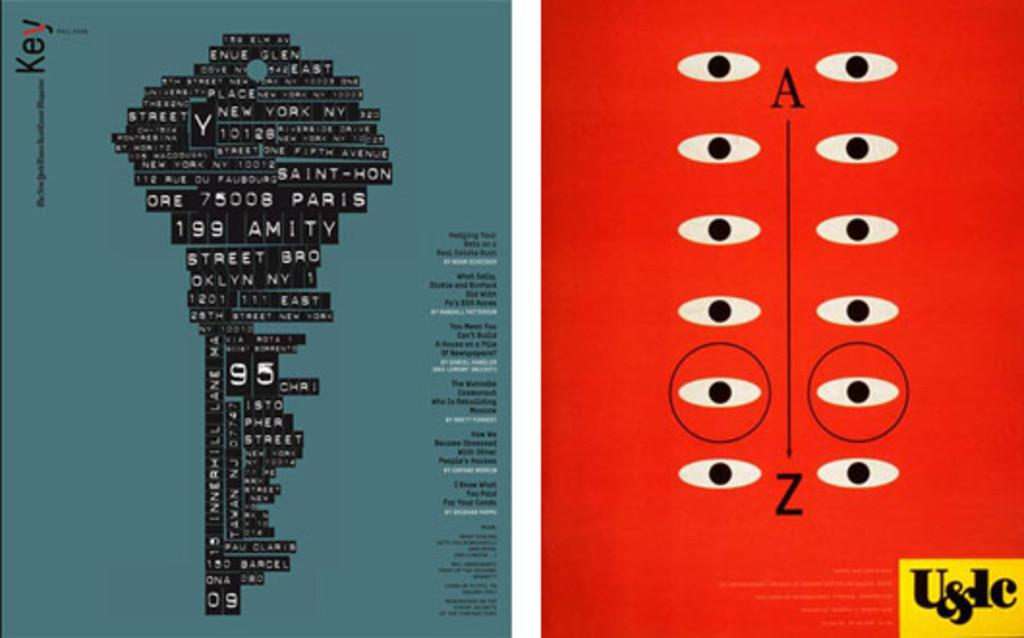<image>
Provide a brief description of the given image. Two posters are side by side, one with a key image and the word key and another with what looks like eyes. 